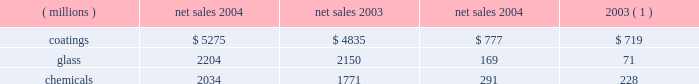Management 2019s discussion and analysis interest expense was $ 17 million less in 2004 than in 2003 reflecting the year over year reduction in debt of $ 316 million .
Other charges declined $ 30 million in 2004 due to a combination of lower environmental remediation , legal and workers compensation expenses and the absence of certain 2003 charges .
Other earnings were $ 28 million higher in 2004 due primarily to higher earnings from our equity affiliates .
The effective tax rate for 2004 was 30.29% ( 30.29 % ) compared to 34.76% ( 34.76 % ) for the full year 2003 .
The reduction in the rate for 2004 reflects the benefit of the subsidy offered pursuant to the medicare act not being subject to tax , the continued improvement in the geographical mix of non- u.s .
Earnings and the favorable resolution during 2004 of matters related to two open u.s .
Federal income tax years .
Net income in 2004 totaled $ 683 million , an increase of $ 189 million over 2003 , and earnings per share 2013 diluted increased $ 1.06 to $ 3.95 per share .
Results of business segments net sales operating income ( millions ) 2004 2003 2004 2003 ( 1 ) coatings $ 5275 $ 4835 $ 777 $ 719 .
Chemicals 2034 1771 291 228 ( 1 ) operating income by segment for 2003 has been revised to reflect a change in the allocation method for certain pension and other postretirement benefit costs in 2004 ( see note 22 , 201cbusiness segment information 201d , under item 8 of this form 10-k ) .
Coatings sales increased $ 440 million or 9% ( 9 % ) in 2004 .
Sales increased 6% ( 6 % ) from improved volumes across all our coatings businesses and 4% ( 4 % ) due to the positive effects of foreign currency translation , primarily from our european operations .
Sales declined 1% ( 1 % ) due to lower selling prices , principally in our automotive business .
Operating income increased $ 58 million in 2004 .
Factors increasing operating income were the higher sales volume ( $ 135 million ) and the favorable effects of currency translation described above and improved manufacturing efficiencies of $ 20 million .
Factors decreasing operating income were inflationary cost increases of $ 82 million and lower selling prices .
Glass sales increased $ 54 million or 3% ( 3 % ) in 2004 .
Sales increased 6% ( 6 % ) from improved volumes primarily from our performance glazings ( flat glass ) , fiber glass , and automotive original equipment businesses net of lower volumes in our automotive replacement glass business .
Sales also increased 2% ( 2 % ) due to the positive effects of foreign currency translation , primarily from our european fiber glass operations .
Sales declined 5% ( 5 % ) due to lower selling prices across all our glass businesses .
Operating income in 2004 increased $ 98 million .
Factors increasing operating income were improved manufacturing efficiencies of $ 110 million , higher sales volume ( $ 53 million ) described above , higher equity earnings and the gains on the sale/leaseback of precious metals of $ 19 million .
The principal factor decreasing operating income was lower selling prices .
Fiber glass volumes were up 15% ( 15 % ) for the year , although pricing declined .
With the shift of electronic printed wiring board production to asia and the volume and pricing gains there , equity earnings from our joint venture serving that region grew in 2004 .
These factors combined with focused cost reductions and manufacturing efficiencies to improve the operating performance of this business , as we continue to position it for future growth in profitability .
Chemicals sales increased $ 263 million or 15% ( 15 % ) in 2004 .
Sales increased 10% ( 10 % ) from improved volumes in our commodity and specialty businesses and 4% ( 4 % ) due to higher selling prices for our commodity products .
Sales also increased 1% ( 1 % ) due to the positive effects of foreign currency translation , primarily from our european operations .
Operating income increased $ 63 million in 2004 .
Factors increasing operating income were the higher selling prices for our commodity products and the higher sales volume ( $ 73 million ) described above , improved manufacturing efficiencies of $ 25 million and lower environmental expenses .
Factors decreasing 2004 operating income were inflationary cost increases of $ 40 million and higher energy costs of $ 79 million .
Other significant factors the company 2019s pension and other postretirement benefit costs for 2004 were $ 45 million lower than in 2003 .
This decrease reflects the market driven growth in pension plan assets that occurred in 2003 , the impact of the $ 140 million in cash contributed to the pension plans by the company in 2004 and the benefit of the subsidy offered pursuant to the medicare act , as discussed in note 12 , 201cpension and other postretirement benefits , 201d under item 8 of this form 10-k .
Commitments and contingent liabilities , including environmental matters ppg is involved in a number of lawsuits and claims , both actual and potential , including some that it has asserted against others , in which substantial monetary damages are sought .
See item 3 , 201clegal proceedings 201d of this form 10-k and note 13 , 201ccommitments and contingent liabilities , 201d under item 8 of this form 10-k for a description of certain of these lawsuits , including a description of the proposed ppg settlement arrangement for asbestos claims announced on may 14 , 2002 .
As discussed in item 3 and note 13 , although the result of any future litigation of such lawsuits and claims is inherently unpredictable , management believes that , in the aggregate , the outcome of all lawsuits and claims involving ppg , including asbestos-related claims in the event the ppg settlement arrangement described in note 13 does not become effective , will not have a material effect on ppg 2019s consolidated financial position or liquidity ; however , any such outcome may be material to the results of operations of any particular period in which costs , if any , are recognized .
The company has been named as a defendant , along with various other co-defendants , in a number of antitrust lawsuits filed in federal and state courts .
These suits allege that ppg acted with competitors to fix prices and allocate markets in the flat glass and automotive refinish industries .
22 2005 ppg annual report and form 10-k .
What would 2004 sales have been in the glass segment without the positive effects of foreign currency translation , in millions? 
Computations: ((1 - 2%) * 2150)
Answer: 2107.0. 